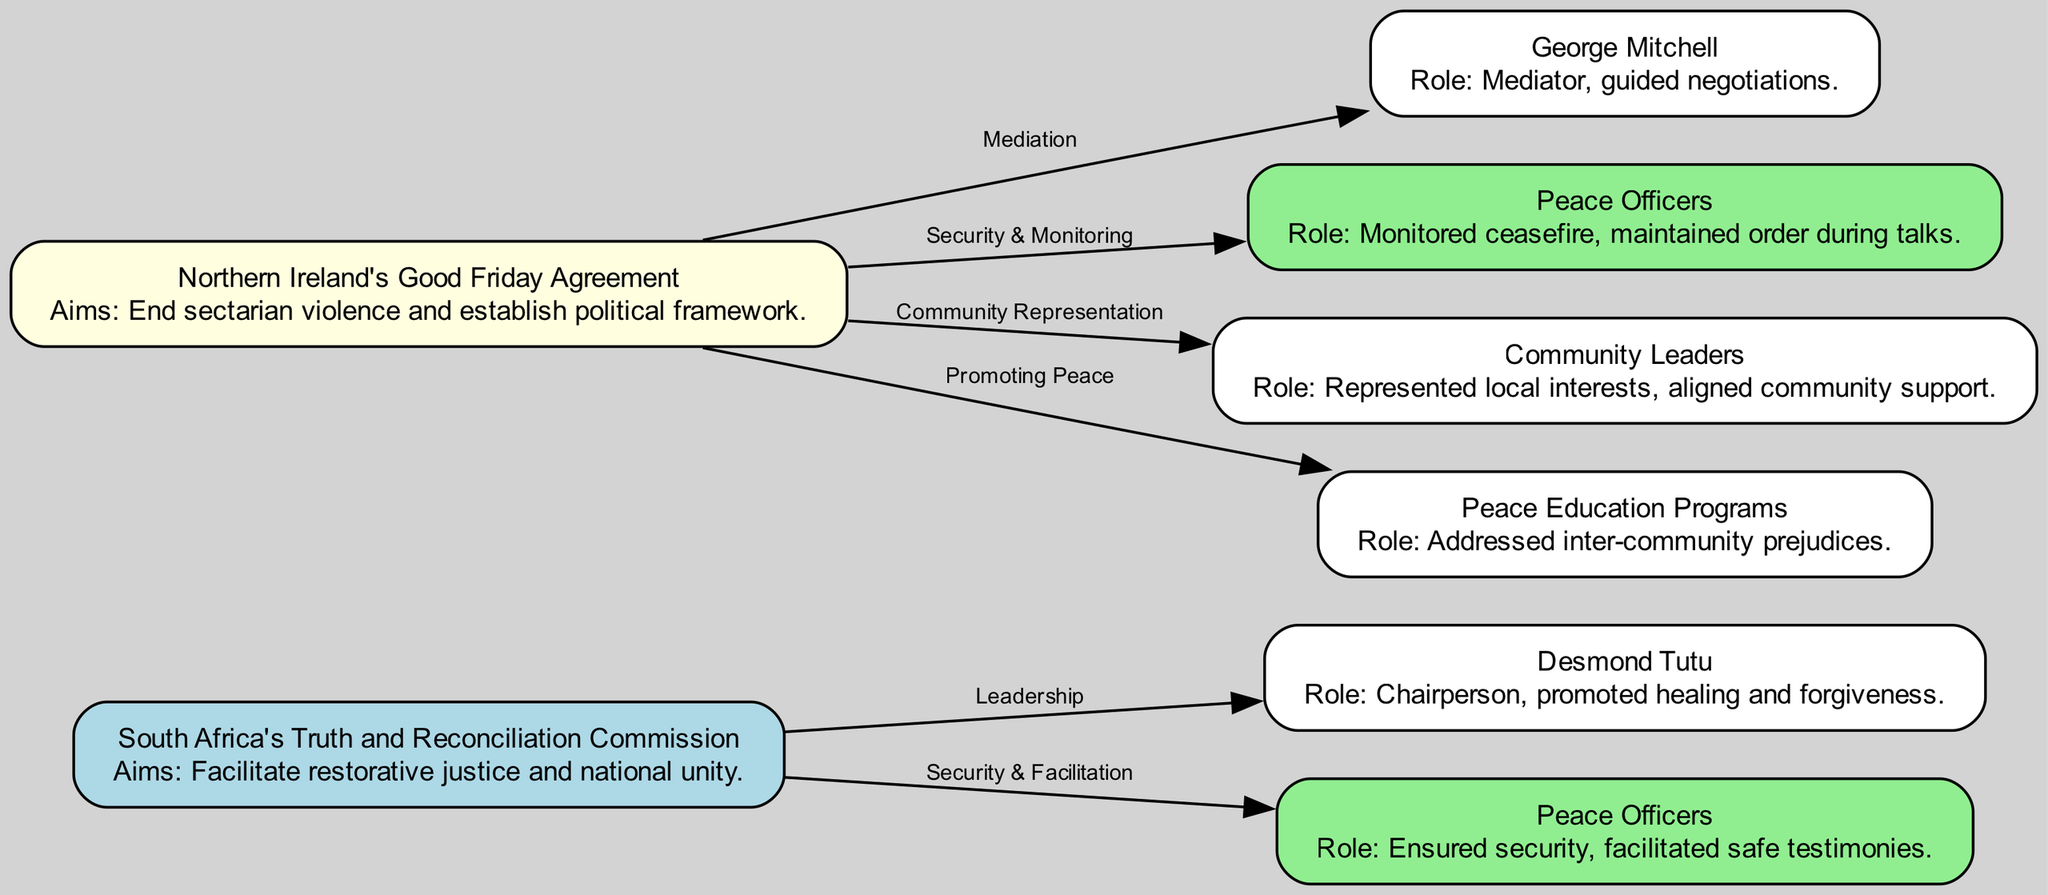What is the main aim of South Africa's Truth and Reconciliation Commission? The diagram indicates that the aim of South Africa's Truth and Reconciliation Commission is to facilitate restorative justice and national unity.
Answer: Facilitate restorative justice and national unity Who chaired South Africa's Truth and Reconciliation Commission? According to the diagram, Desmond Tutu is identified as the chairperson of South Africa's Truth and Reconciliation Commission.
Answer: Desmond Tutu What role did peace officers play in Northern Ireland's Good Friday Agreement? The diagram specifies that peace officers monitored ceasefire and maintained order during talks related to Northern Ireland's Good Friday Agreement.
Answer: Monitored ceasefire, maintained order during talks What is the relationship between Northern Ireland's Good Friday Agreement and community leaders? The diagram shows that community leaders are involved in the representation of local interests, which is linked to Northern Ireland's Good Friday Agreement.
Answer: Community Representation How many nodes represent peace officers in the diagram? Reviewing the diagram, there are two representations of peace officers, one for each case study (South Africa and Northern Ireland).
Answer: Two What was George Mitchell's role in the Northern Ireland's Good Friday Agreement? The diagram states that George Mitchell acted as a mediator who guided negotiations for the Good Friday Agreement in Northern Ireland.
Answer: Mediator, guided negotiations Which peacebuilding initiative involved promoting peace education programs? The diagram indicates that peace education programs are associated with Northern Ireland's Good Friday Agreement, which is focused on addressing inter-community prejudices.
Answer: Northern Ireland's Good Friday Agreement How do the peace officers' roles in South Africa's Truth and Reconciliation Commission and Northern Ireland's Good Friday Agreement differ? In South Africa's TRC, peace officers ensured security and facilitated safe testimonies, while in Northern Ireland, they monitored ceasefire and maintained order during talks. This shows a difference in emphasis on security/facilitation versus monitoring.
Answer: Ensure security and facilitate for TRC; Monitor ceasefire for GFA 